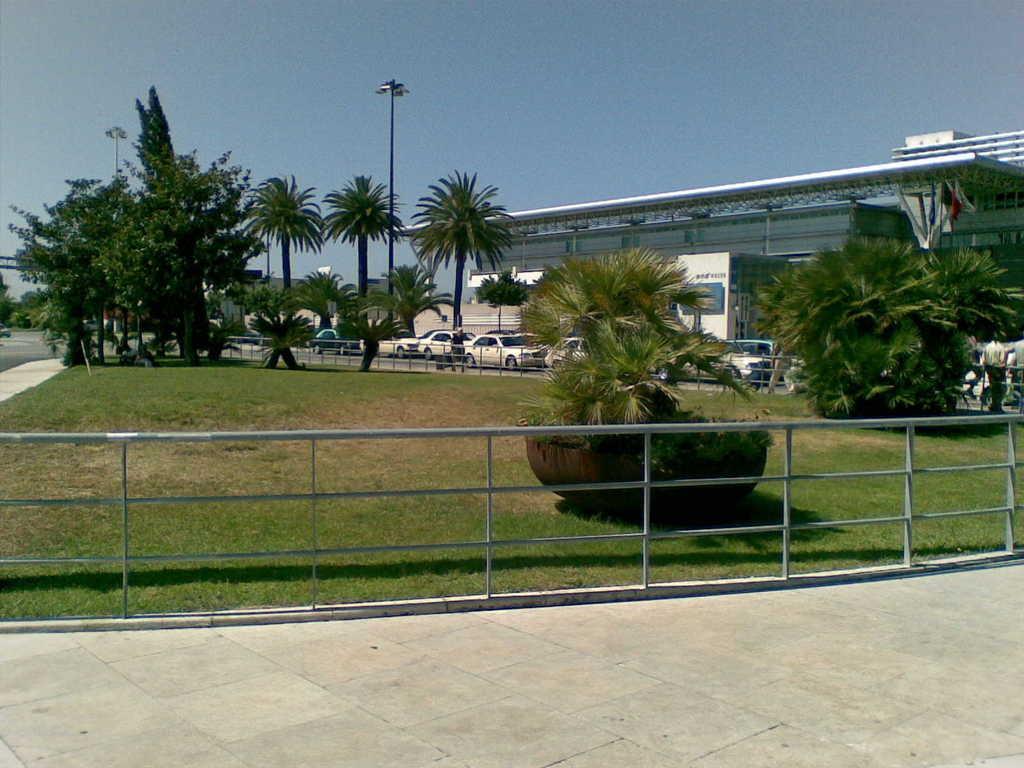Could you give a brief overview of what you see in this image? As we can see in the image there are trees, vehicles and buildings. There is grass and at the top there is sky. There are few people. 